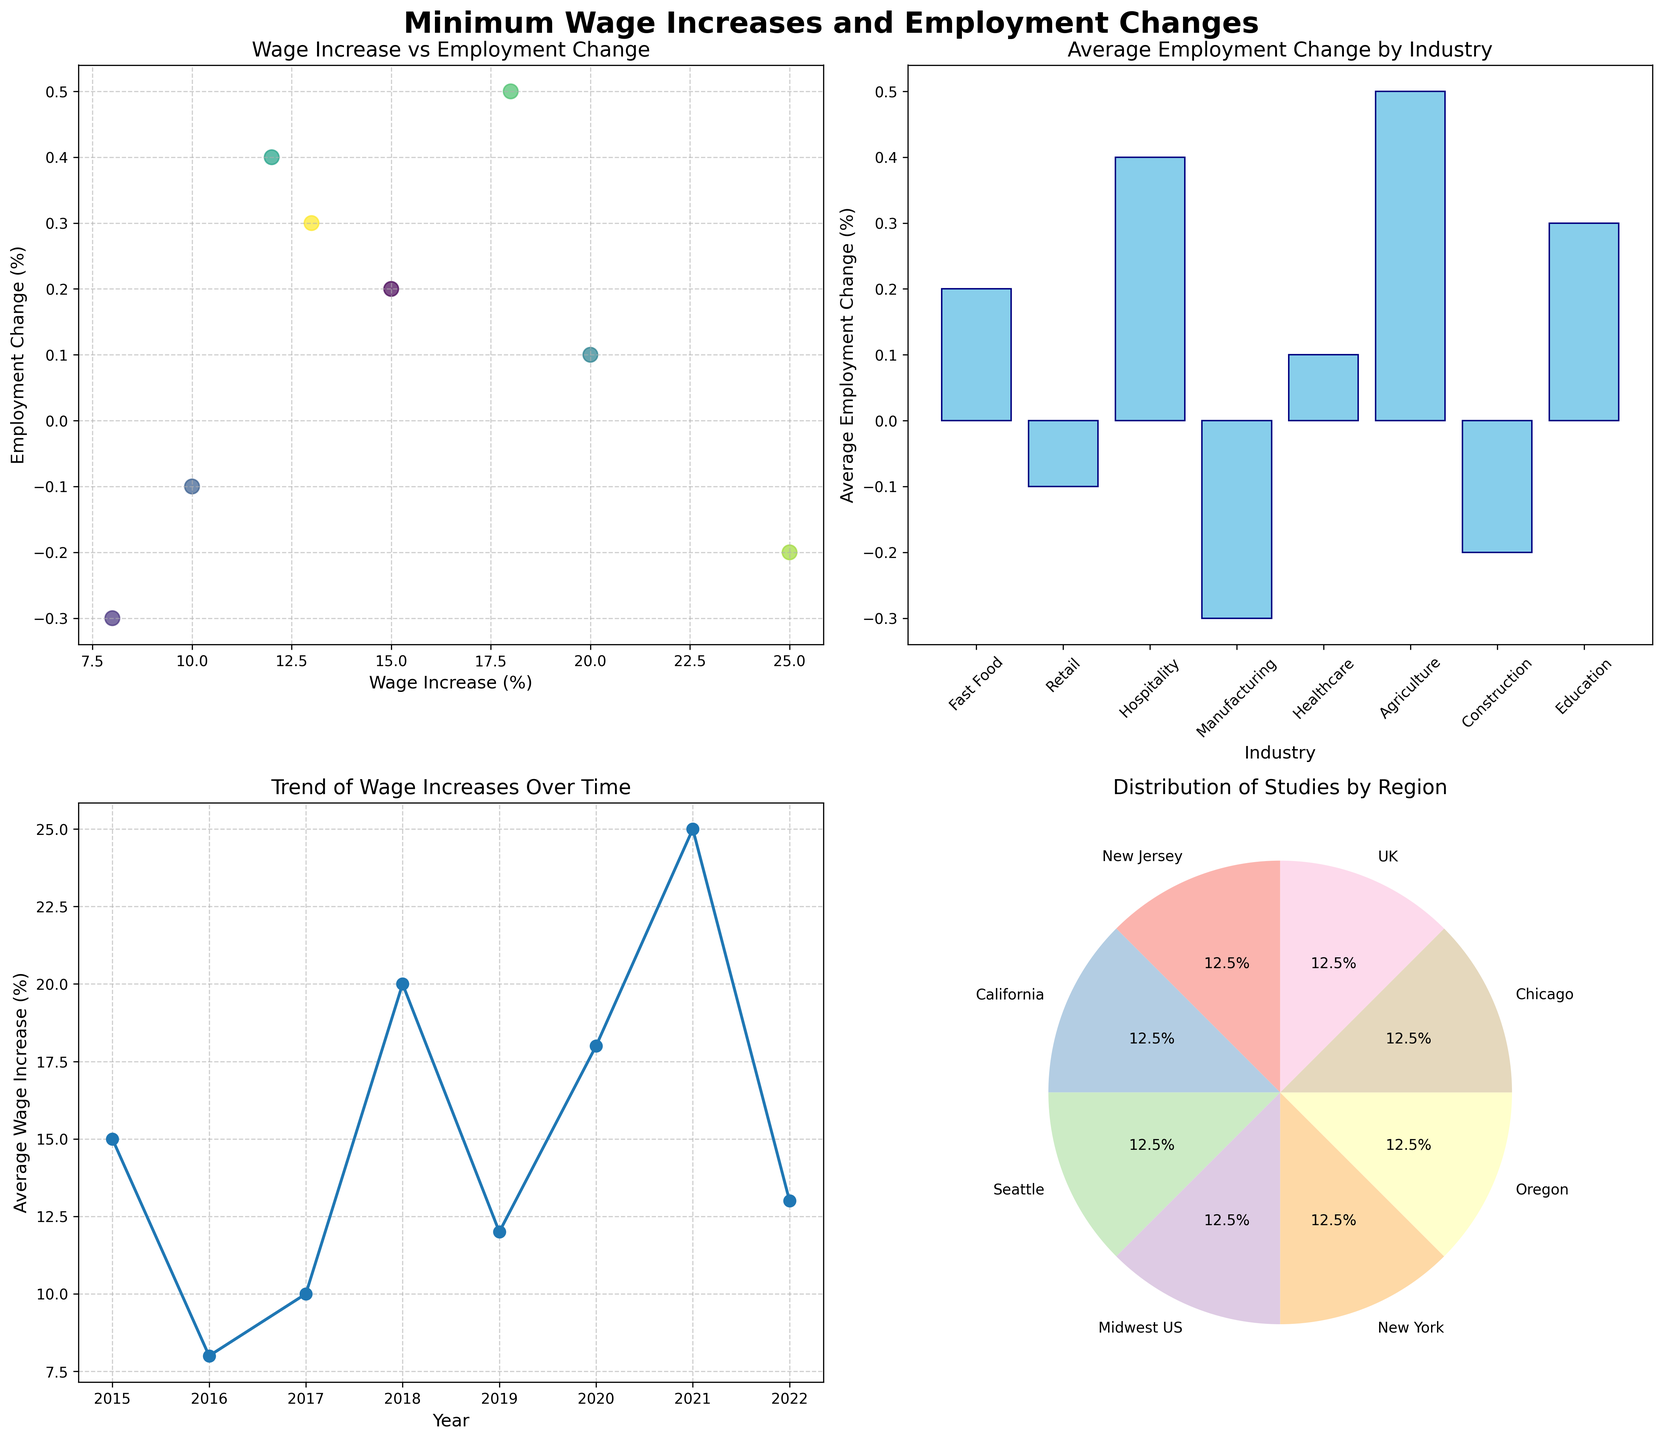what is the title of the scatter plot in the top left? The scatter plot in the top left contains a title above it. The title reads "Wage Increase vs Employment Change" which summarizes the content of the scatter plot.
Answer: Wage Increase vs Employment Change what is the average employment change (%) in the retail industry? To find the average employment change, look at the bar plot in the top right. Identify the bar representing the retail industry and note its height, which represents the average employment change in this industry.
Answer: -0.1% how many studies are represented from the Midwest US? The pie chart in the bottom right shows the distribution of studies by region. To find the number of studies from the Midwest US, look at the slice labeled 'Midwest US' and count the entries in the data list that come from this region.
Answer: 1 in which year was the lowest average wage increase (%) observed? Refer to the line plot in the bottom left, which tracks wage increases over time. Identify the point on the line plot that represents the minimum value and note its corresponding year.
Answer: 2016 what is the color scheme used for the scatter plot points? The scatter plot points are colored according to a range, as represented by the color map 'viridis'. This means the colors transition from yellow to green to blue as the year changes.
Answer: viridis which study saw the highest wage increase (%) and what was the corresponding employment change (%)? In the scatter plot, find the point situated at the highest value on the Wage Increase (%) axis. Identify the study associated with this point by its color and corresponding data in the chart's legend. The highest wage increase is from Jardim et al. with a corresponding employment change of -0.2%.
Answer: Jardim et al., -0.2% what industry experienced the lowest average employment change (%)? In the bar plot, note the heights of the bars for each industry. The bar with the smallest height represents the industry with the lowest average employment change.
Answer: Manufacturing describe the trend of wage increases over the years depicted in the line plot. The line plot shows the average wage increases per year. From this plot, we observe a somewhat fluctuating trend: starting at around 15% in 2015, dipping to around 8% in 2016, and gradually increasing, peaking at 25% in 2021 before slightly decreasing.
Answer: Fluctuating how does the average employment change in agriculture compare to the healthcare sector? In the bar plot, compare the heights of the bars for agriculture and healthcare industries to determine which one has a higher average employment change.
Answer: Agriculture > Healthcare which region has the highest representation of studies and what percentage does it represent? Examine the pie chart and identify the region with the largest slice, look at the percentage label on that slice to find the exact percentage. This would be the region with the highest representation of studies.
Answer: New Jersey, 12.5% 